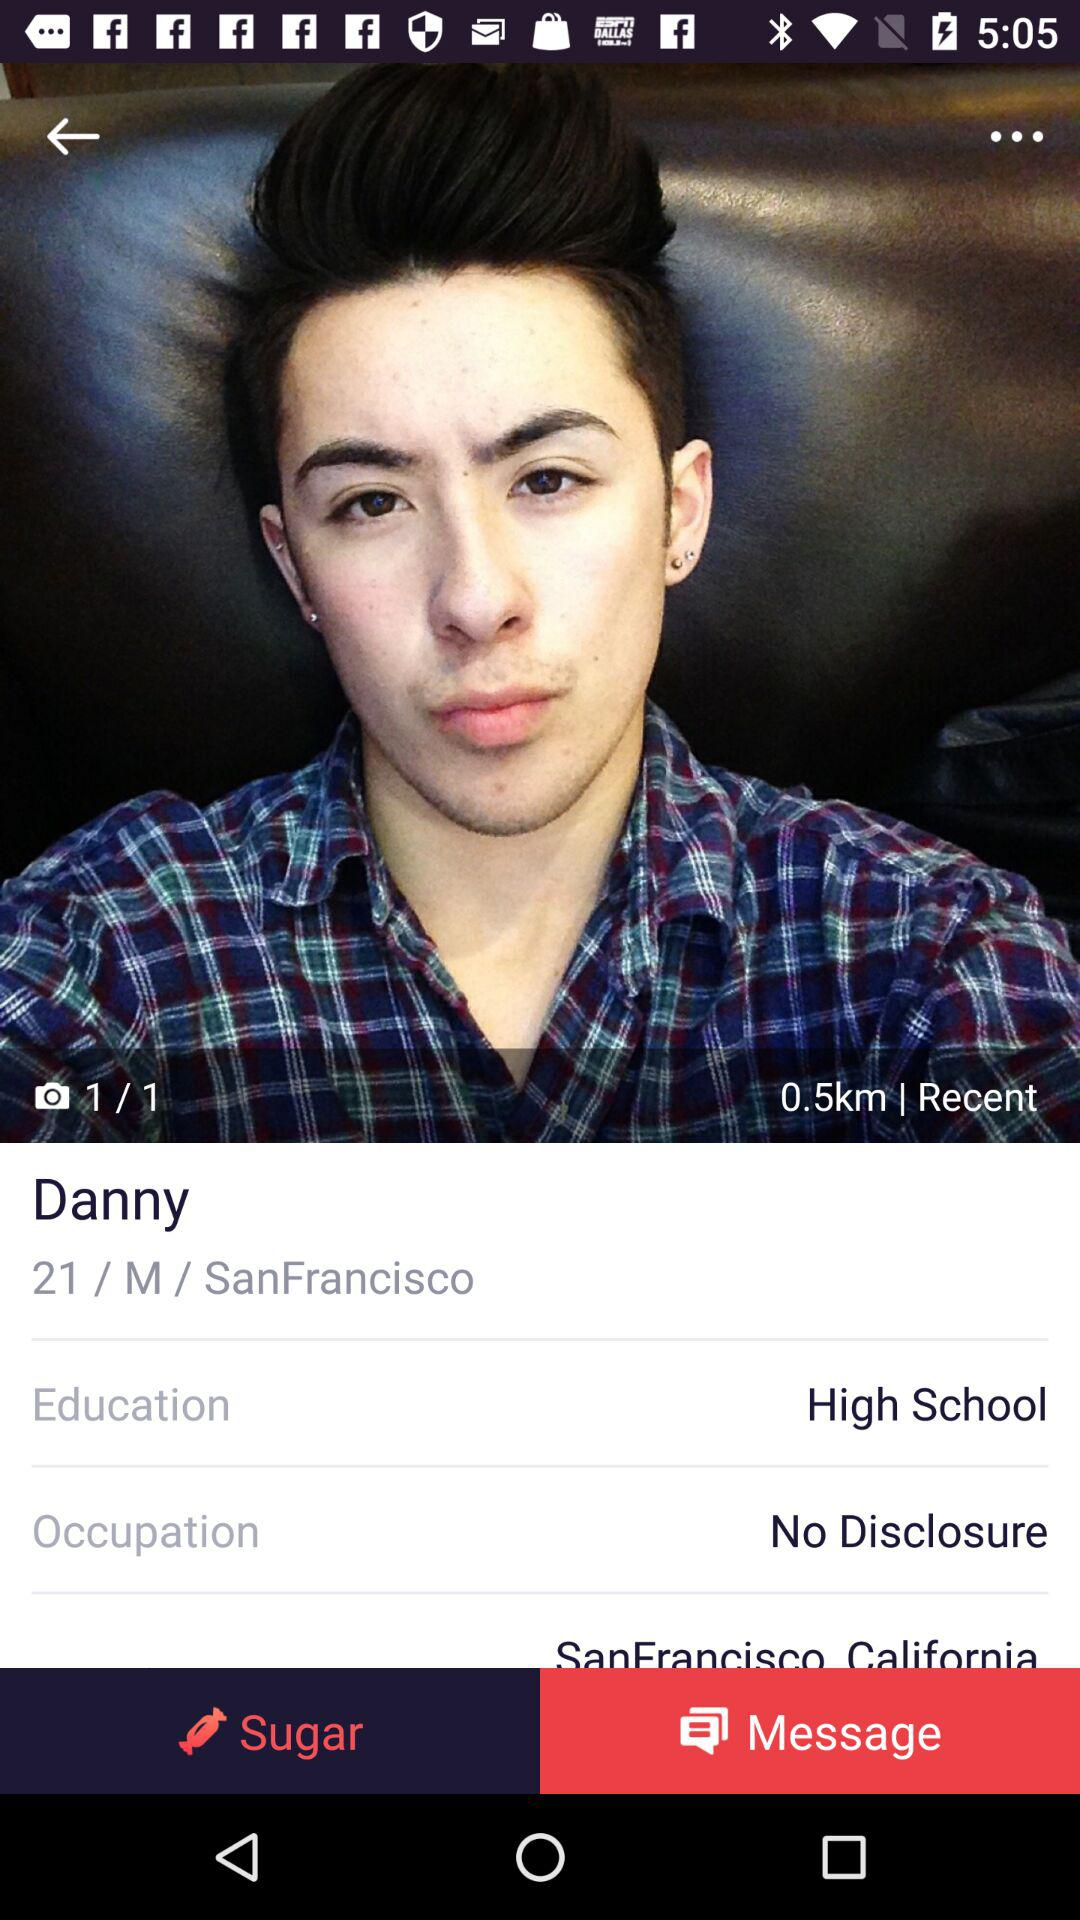What is Danny's educational background? Danny's educational background is high school. 